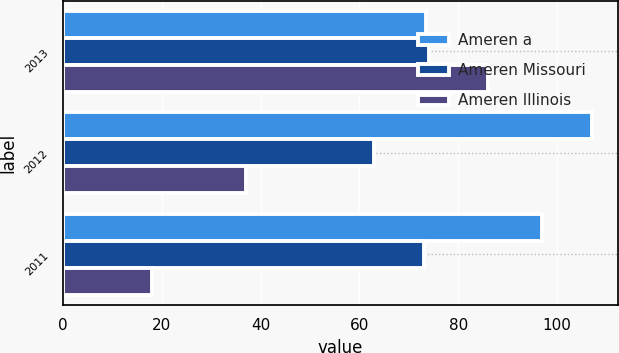Convert chart. <chart><loc_0><loc_0><loc_500><loc_500><stacked_bar_chart><ecel><fcel>2013<fcel>2012<fcel>2011<nl><fcel>Ameren a<fcel>73.5<fcel>107<fcel>97<nl><fcel>Ameren Missouri<fcel>74<fcel>63<fcel>73<nl><fcel>Ameren Illinois<fcel>86<fcel>37<fcel>18<nl></chart> 